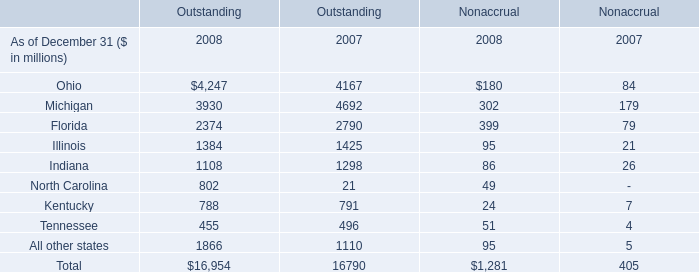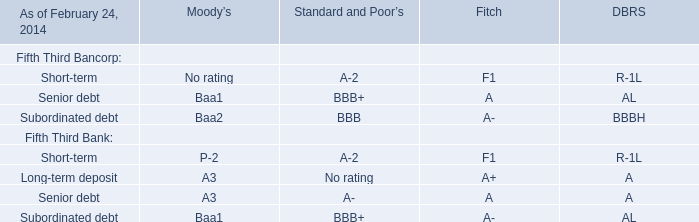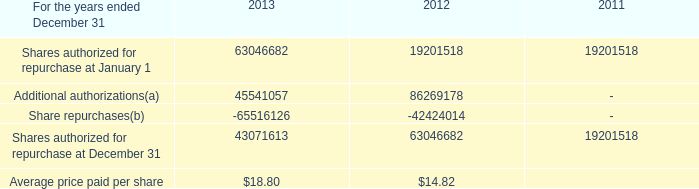what is the growth rate in the average price paid per share from 2012 to 2013? 
Computations: ((18.80 - 14.82) / 14.82)
Answer: 0.26856. 